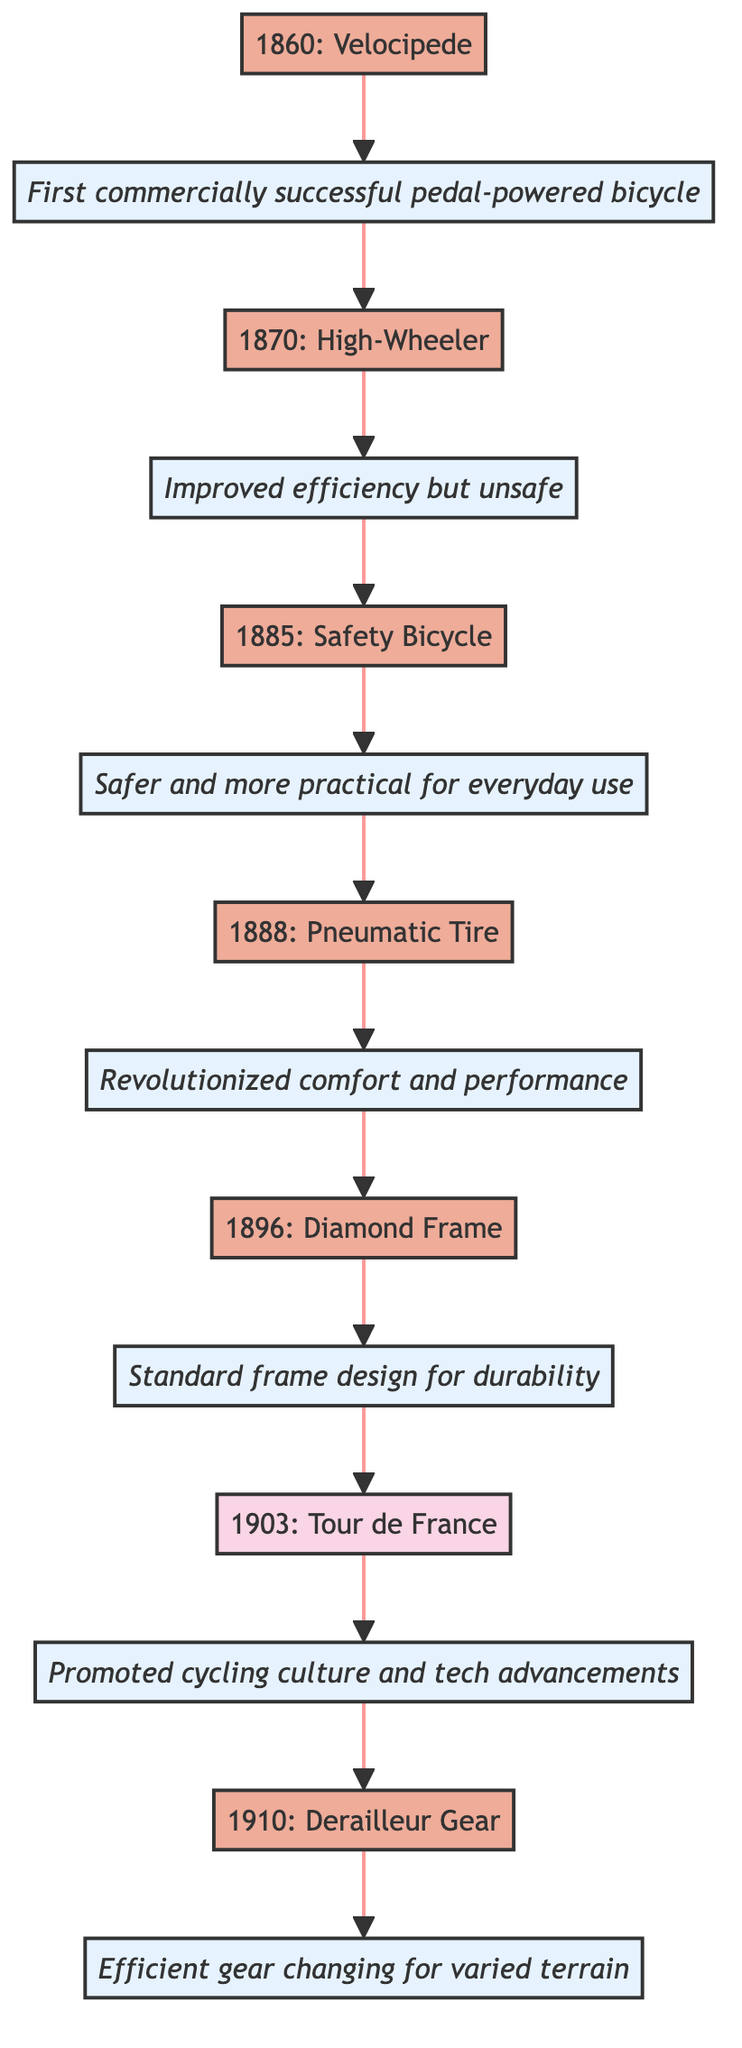What year was the Safety Bicycle invented? The diagram shows that the invention of the Safety Bicycle occurred in the year 1885. This can be directly found at the node corresponding to the "Safety Bicycle."
Answer: 1885 Who invented the Pneumatic Tire? According to the diagram, the Pneumatic Tire was invented by John Boyd Dunlop. This name is mentioned at the corresponding node for the Pneumatic Tire, providing the inventor's name directly.
Answer: John Boyd Dunlop What was the impact of the High-Wheeler? The impact of the High-Wheeler is described as “Improved efficiency but unsafe,” which is clearly stated at the impact node connected to the High-Wheeler node in the diagram.
Answer: Improved efficiency but unsafe How many inventions are shown in the timeline? By counting the invention nodes represented in the diagram, there are five distinctive inventions listed: Velocipede, High-Wheeler, Safety Bicycle, Pneumatic Tire, and Diamond Frame, resulting in a total of five inventions.
Answer: 5 Which advancement came after the Diamond Frame? Tracing the flow from the Diamond Frame node, the next advancement in the timeline is the Tour de France event in 1903, showing the progression in the timeline.
Answer: Tour de France What was the major innovation introduced in 1910? The diagram indicates that in 1910, the Derailleur Gear System was introduced. This information can be found directly in the node for the year 1910.
Answer: Derailleur Gear System What are the two countries listed where inventions took place? The diagram shows that notable inventions occurred in France and the United Kingdom. By examining the diagram, we can find the countries associated with the relevant nodes such as the Velocipede, Pneumatic Tire, and others.
Answer: France, United Kingdom Which event in the timeline promoted cycling culture? The Tour de France in 1903 is identified in the diagram as the event that promoted cycling culture and technological advancements through competitive racing, making it distinct for this purpose.
Answer: Tour de France 